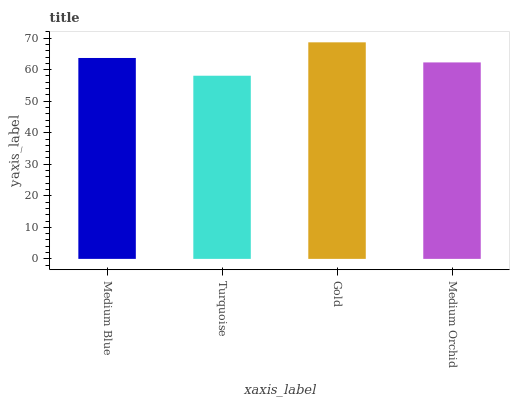Is Turquoise the minimum?
Answer yes or no. Yes. Is Gold the maximum?
Answer yes or no. Yes. Is Gold the minimum?
Answer yes or no. No. Is Turquoise the maximum?
Answer yes or no. No. Is Gold greater than Turquoise?
Answer yes or no. Yes. Is Turquoise less than Gold?
Answer yes or no. Yes. Is Turquoise greater than Gold?
Answer yes or no. No. Is Gold less than Turquoise?
Answer yes or no. No. Is Medium Blue the high median?
Answer yes or no. Yes. Is Medium Orchid the low median?
Answer yes or no. Yes. Is Gold the high median?
Answer yes or no. No. Is Turquoise the low median?
Answer yes or no. No. 